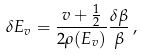<formula> <loc_0><loc_0><loc_500><loc_500>\delta E _ { v } = \frac { v + \frac { 1 } { 2 } } { 2 \rho ( E _ { v } ) } \frac { \delta \beta } { \beta } \, ,</formula> 